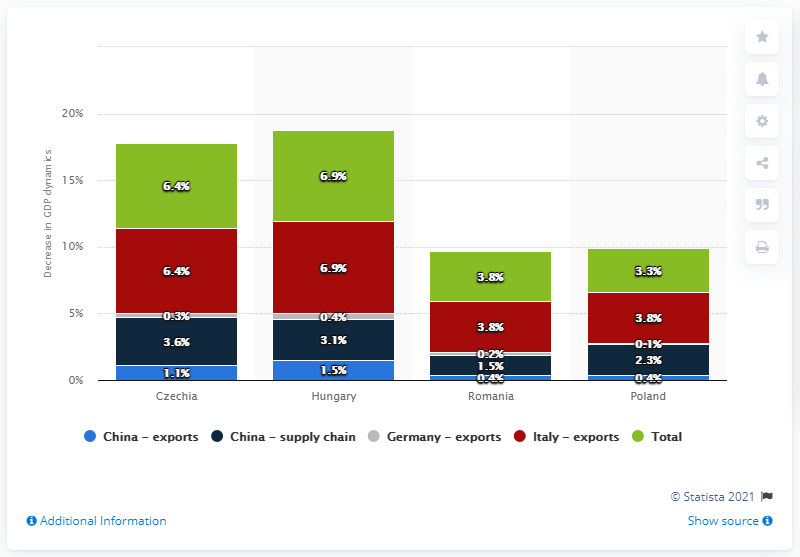Draw attention to some important aspects in this diagram. The forecasted decrease in GDP for Poland is expected to be 3.3%. According to estimates, the GDP of Hungary is expected to decline by 6.9% in the coming year. 